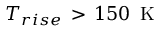<formula> <loc_0><loc_0><loc_500><loc_500>T _ { r i s e } \, > \, 1 5 0 \, K</formula> 